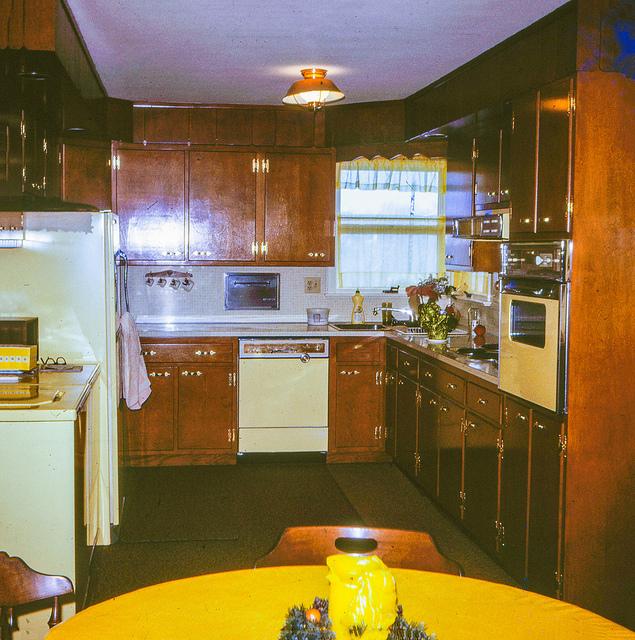Has the kitchen been renovated recently?
Short answer required. No. Is the kitchen counter cluttered?
Answer briefly. Yes. What color is the table?
Give a very brief answer. Yellow. 